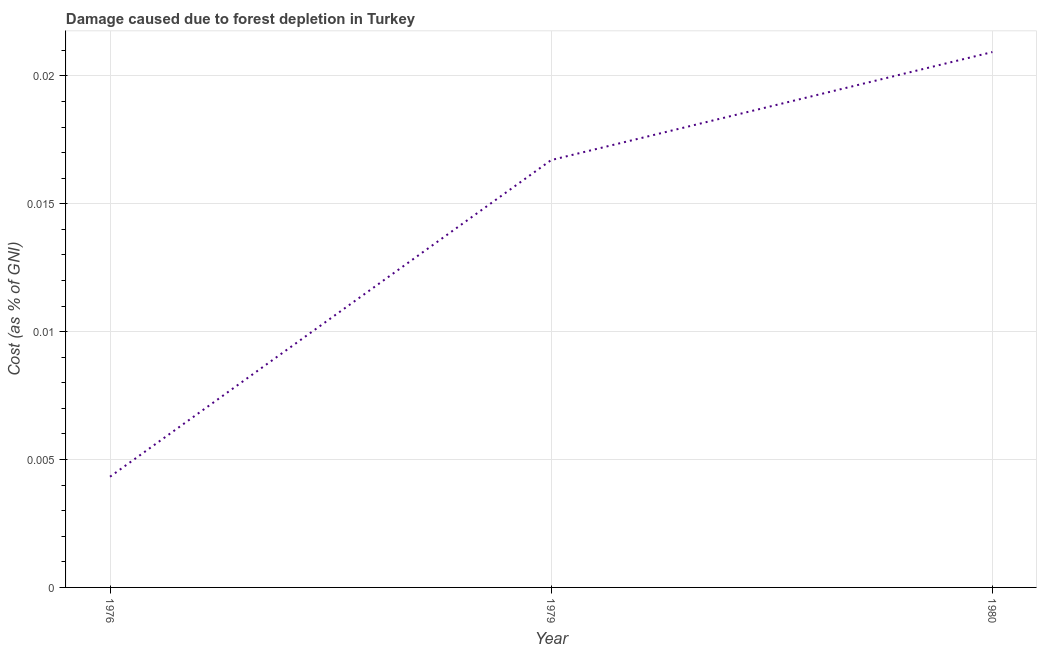What is the damage caused due to forest depletion in 1976?
Your answer should be very brief. 0. Across all years, what is the maximum damage caused due to forest depletion?
Your answer should be very brief. 0.02. Across all years, what is the minimum damage caused due to forest depletion?
Your answer should be very brief. 0. In which year was the damage caused due to forest depletion maximum?
Make the answer very short. 1980. In which year was the damage caused due to forest depletion minimum?
Provide a short and direct response. 1976. What is the sum of the damage caused due to forest depletion?
Keep it short and to the point. 0.04. What is the difference between the damage caused due to forest depletion in 1979 and 1980?
Offer a terse response. -0. What is the average damage caused due to forest depletion per year?
Keep it short and to the point. 0.01. What is the median damage caused due to forest depletion?
Your response must be concise. 0.02. Do a majority of the years between 1979 and 1980 (inclusive) have damage caused due to forest depletion greater than 0.003 %?
Make the answer very short. Yes. What is the ratio of the damage caused due to forest depletion in 1976 to that in 1980?
Your response must be concise. 0.21. What is the difference between the highest and the second highest damage caused due to forest depletion?
Offer a very short reply. 0. Is the sum of the damage caused due to forest depletion in 1976 and 1979 greater than the maximum damage caused due to forest depletion across all years?
Your answer should be very brief. Yes. What is the difference between the highest and the lowest damage caused due to forest depletion?
Make the answer very short. 0.02. How many lines are there?
Your answer should be compact. 1. How many years are there in the graph?
Provide a succinct answer. 3. What is the difference between two consecutive major ticks on the Y-axis?
Provide a short and direct response. 0.01. Are the values on the major ticks of Y-axis written in scientific E-notation?
Make the answer very short. No. What is the title of the graph?
Ensure brevity in your answer.  Damage caused due to forest depletion in Turkey. What is the label or title of the X-axis?
Offer a terse response. Year. What is the label or title of the Y-axis?
Offer a terse response. Cost (as % of GNI). What is the Cost (as % of GNI) in 1976?
Offer a terse response. 0. What is the Cost (as % of GNI) in 1979?
Keep it short and to the point. 0.02. What is the Cost (as % of GNI) in 1980?
Provide a succinct answer. 0.02. What is the difference between the Cost (as % of GNI) in 1976 and 1979?
Offer a very short reply. -0.01. What is the difference between the Cost (as % of GNI) in 1976 and 1980?
Provide a succinct answer. -0.02. What is the difference between the Cost (as % of GNI) in 1979 and 1980?
Give a very brief answer. -0. What is the ratio of the Cost (as % of GNI) in 1976 to that in 1979?
Your answer should be compact. 0.26. What is the ratio of the Cost (as % of GNI) in 1976 to that in 1980?
Your answer should be very brief. 0.21. What is the ratio of the Cost (as % of GNI) in 1979 to that in 1980?
Provide a short and direct response. 0.8. 